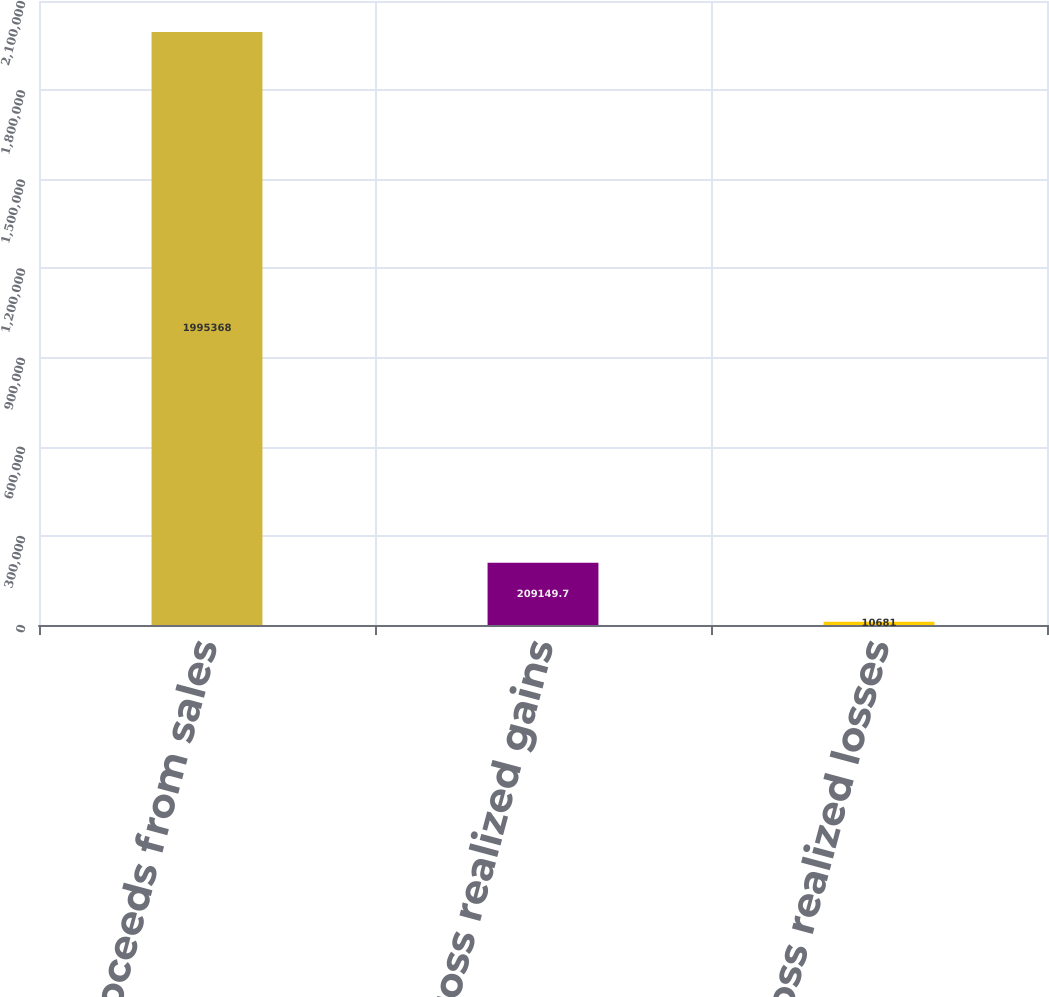Convert chart to OTSL. <chart><loc_0><loc_0><loc_500><loc_500><bar_chart><fcel>Proceeds from sales<fcel>Gross realized gains<fcel>Gross realized losses<nl><fcel>1.99537e+06<fcel>209150<fcel>10681<nl></chart> 